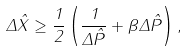Convert formula to latex. <formula><loc_0><loc_0><loc_500><loc_500>\Delta \hat { X } \geq \frac { 1 } { 2 } \left ( \frac { 1 } { \Delta \hat { P } } + \beta \Delta \hat { P } \right ) ,</formula> 